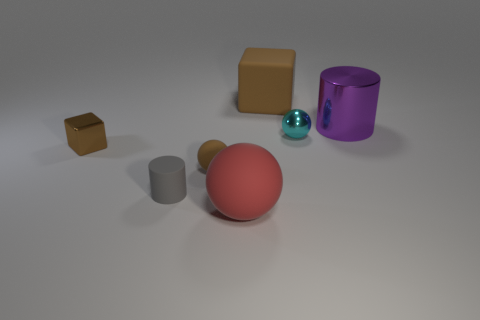How many rubber spheres have the same size as the cyan metallic sphere?
Your answer should be very brief. 1. Do the matte block and the cyan shiny ball have the same size?
Offer a terse response. No. There is a object that is on the right side of the small brown sphere and on the left side of the big brown block; what is its size?
Ensure brevity in your answer.  Large. Are there more purple shiny cylinders that are to the left of the large purple thing than red things that are on the left side of the brown rubber sphere?
Keep it short and to the point. No. What is the color of the large metal thing that is the same shape as the tiny gray object?
Offer a terse response. Purple. Does the small rubber thing behind the tiny gray cylinder have the same color as the rubber cube?
Ensure brevity in your answer.  Yes. What number of small rubber objects are there?
Your response must be concise. 2. Is the red ball that is left of the cyan metallic object made of the same material as the tiny gray cylinder?
Offer a very short reply. Yes. How many cubes are to the right of the tiny brown thing that is behind the ball on the left side of the big red thing?
Ensure brevity in your answer.  1. How big is the brown matte ball?
Your answer should be very brief. Small. 